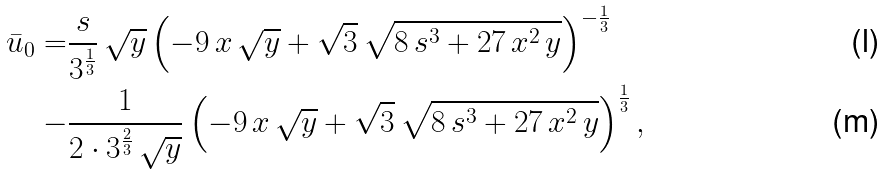Convert formula to latex. <formula><loc_0><loc_0><loc_500><loc_500>\bar { u } _ { 0 } = & \frac { s } { 3 ^ { \frac { 1 } { 3 } } } \, { \sqrt { y } } \, { \left ( - 9 \, x \, { \sqrt { y } } + { \sqrt { 3 } } \, { \sqrt { 8 \, s ^ { 3 } + 2 7 \, x ^ { 2 } \, y } } \right ) } ^ { - \frac { 1 } { 3 } } \\ - & \frac { 1 } { 2 \cdot 3 ^ { \frac { 2 } { 3 } } \, { \sqrt { y } } } \left ( - 9 \, x \, { \sqrt { y } } + { \sqrt { 3 } } \, { \sqrt { 8 \, s ^ { 3 } + 2 7 \, x ^ { 2 } \, y } } \right ) ^ { \frac { 1 } { 3 } } ,</formula> 